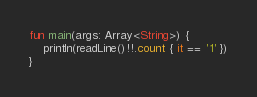Convert code to text. <code><loc_0><loc_0><loc_500><loc_500><_Kotlin_>fun main(args: Array<String>) {
    println(readLine()!!.count { it == '1' })
}</code> 